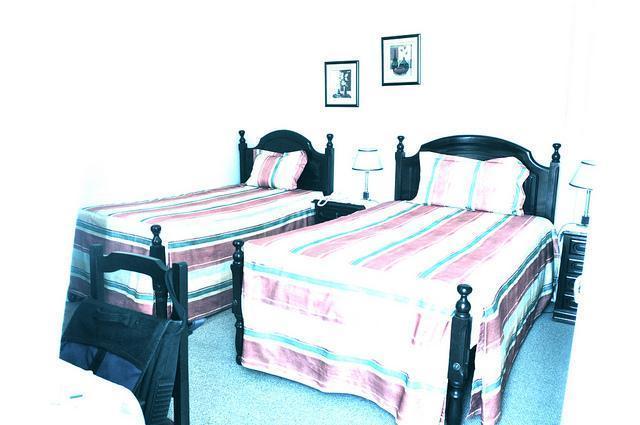How many beds are there?
Give a very brief answer. 2. How many beds are visible?
Give a very brief answer. 2. 